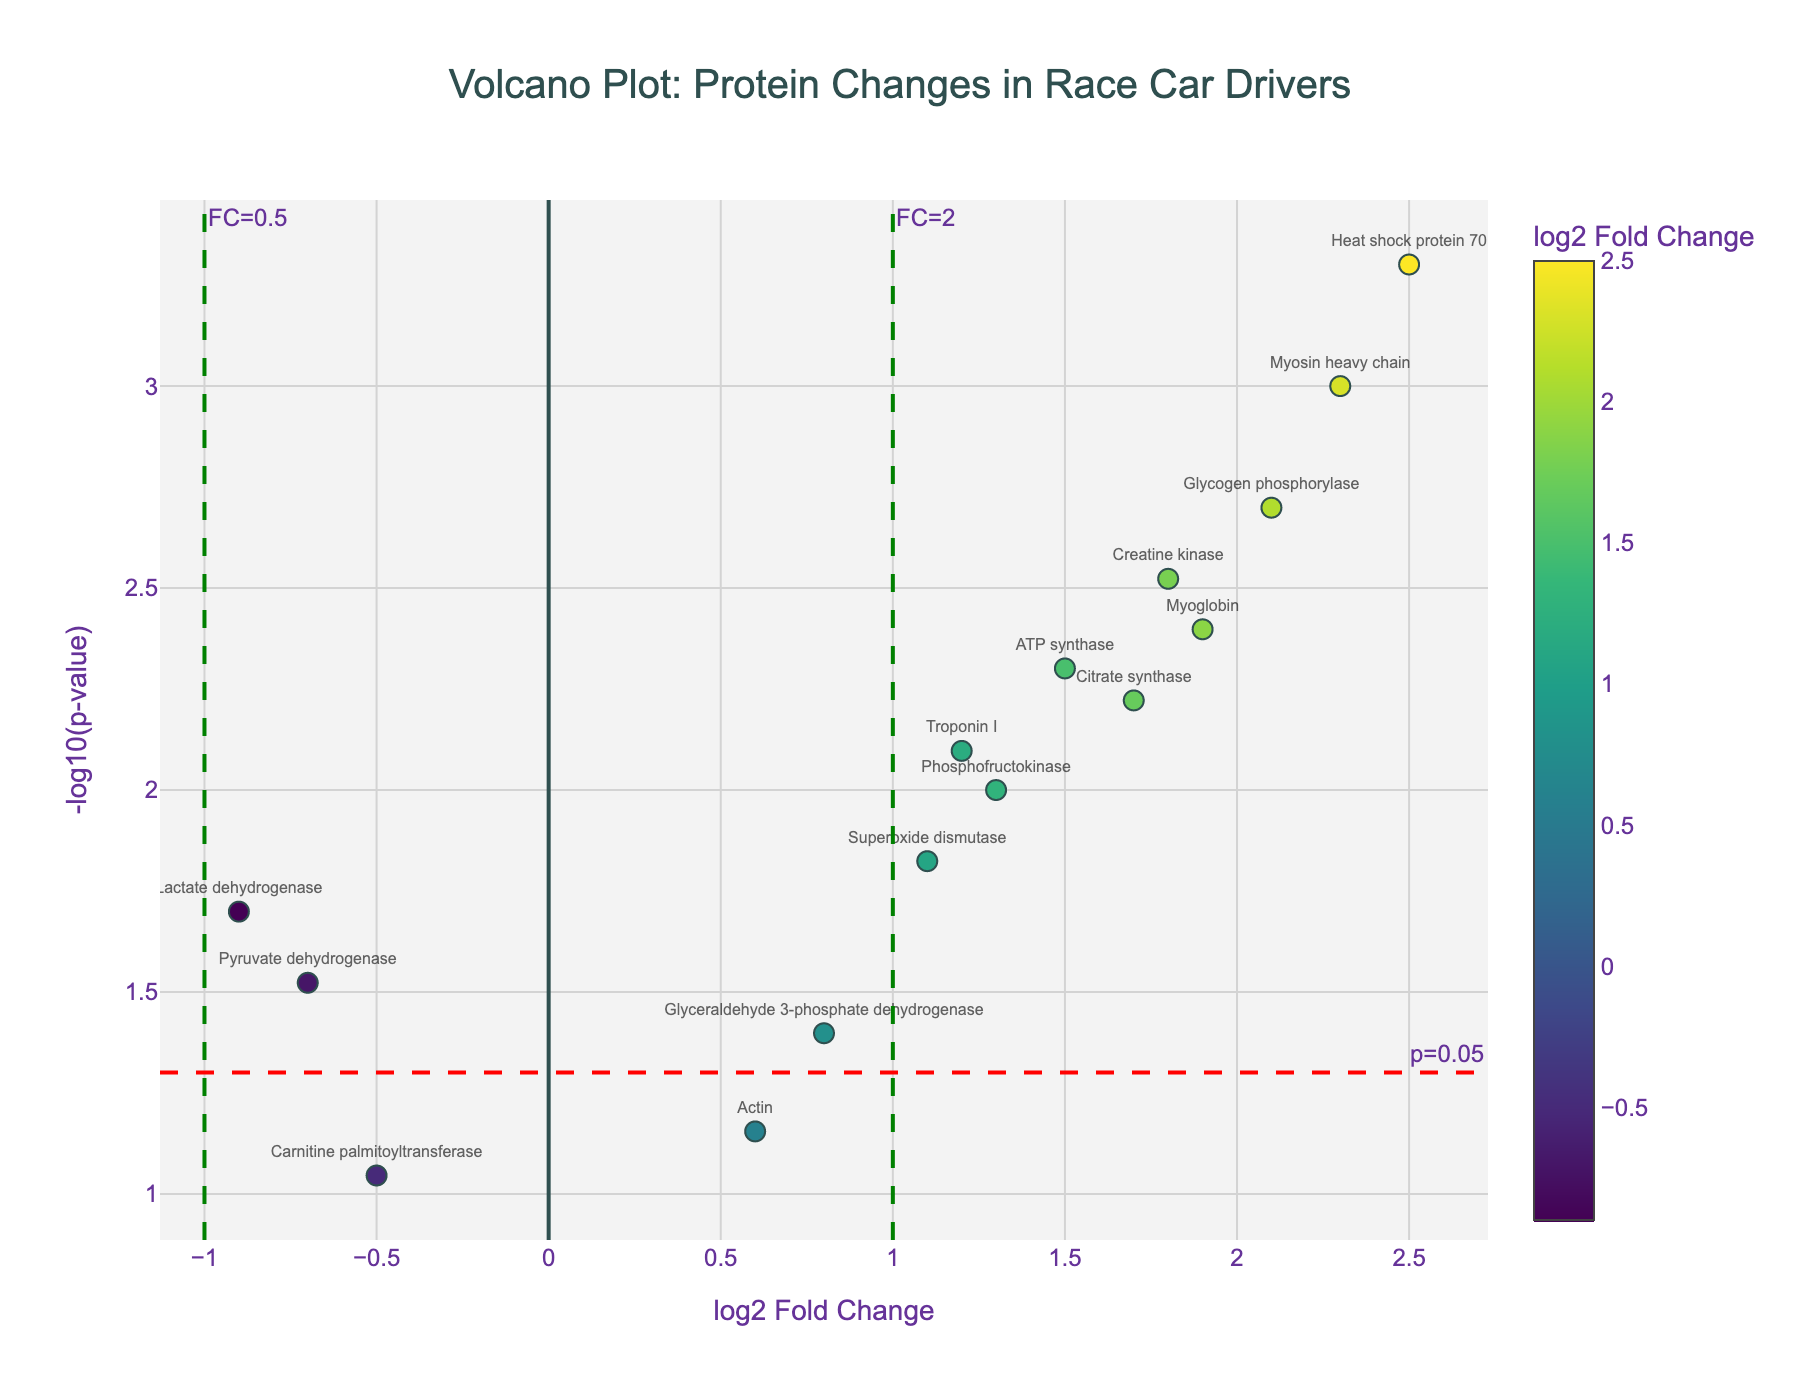What is the title of the figure? The title of the figure is located at the top of the plot.
Answer: Volcano Plot: Protein Changes in Race Car Drivers What are the x-axis and y-axis labels? The x-axis label is "log2 Fold Change" and the y-axis label is "-log10(p-value)".
Answer: log2 Fold Change, -log10(p-value) Which protein shows the highest -log10(p-value)? By looking at the y-axis, the highest point on the plot represents the highest -log10(p-value).
Answer: Heat shock protein 70 Which proteins have log2 Fold Change values greater than 1? Look at the x-axis values and identify the proteins positioned to the right of the green line at log2 Fold Change of 1.
Answer: Myosin heavy chain, Creatine kinase, Glycogen phosphorylase, Myoglobin, ATP synthase, Heat shock protein 70, Phosphofructokinase, Citrate synthase Which protein has the highest log2 Fold Change? Find the protein located furthest to the right on the x-axis of the plot.
Answer: Heat shock protein 70 How many proteins have a p-value less than 0.05? Proteins with a -log10(p-value) above the red dashed line (y = -log10(0.05)) have p-values less than 0.05. Count these points.
Answer: 11 Which proteins show a significant decrease in fold change? Identify proteins with negative log2 Fold Change values that are below -1 and above the red dashed line for p-value significance.
Answer: Lactate dehydrogenase, Pyruvate dehydrogenase Compare the log2 Fold Change of Myosin heavy chain and Myoglobin. Which is higher? Look at the x-axis values of both proteins. Compare their positions horizontally.
Answer: Myosin heavy chain Which data points fall near the (0,0) point on the plot? Identify proteins with x and y values close to zero on both axes.
Answer: Actin What is the significance threshold for p-values in this plot? The red dashed line is marked at y = -log10(0.05), indicating the significance threshold for p-values.
Answer: 0.05 